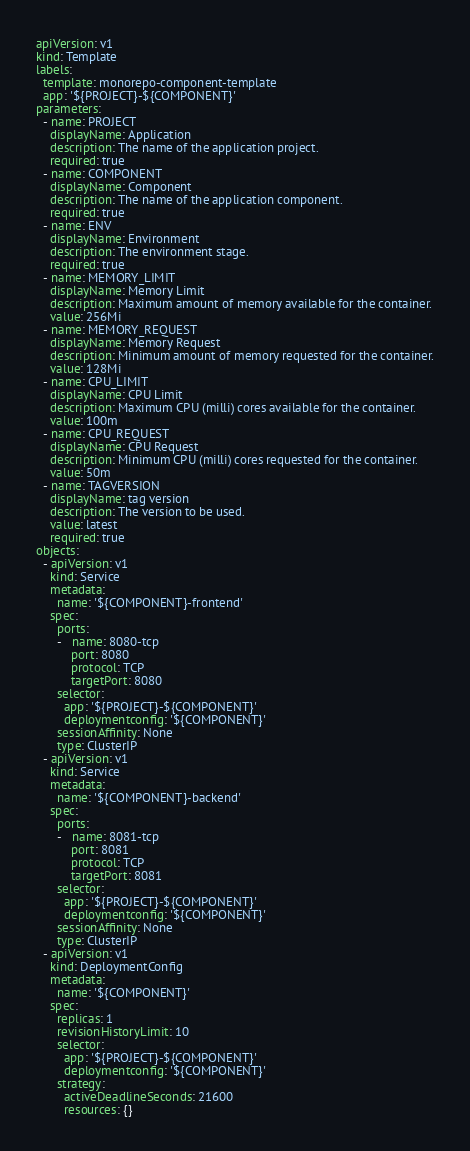Convert code to text. <code><loc_0><loc_0><loc_500><loc_500><_YAML_>apiVersion: v1
kind: Template
labels:
  template: monorepo-component-template
  app: '${PROJECT}-${COMPONENT}'
parameters:
  - name: PROJECT
    displayName: Application
    description: The name of the application project.
    required: true
  - name: COMPONENT
    displayName: Component
    description: The name of the application component.
    required: true
  - name: ENV
    displayName: Environment
    description: The environment stage.
    required: true
  - name: MEMORY_LIMIT
    displayName: Memory Limit
    description: Maximum amount of memory available for the container.
    value: 256Mi
  - name: MEMORY_REQUEST
    displayName: Memory Request
    description: Minimum amount of memory requested for the container.
    value: 128Mi
  - name: CPU_LIMIT
    displayName: CPU Limit
    description: Maximum CPU (milli) cores available for the container.
    value: 100m
  - name: CPU_REQUEST
    displayName: CPU Request
    description: Minimum CPU (milli) cores requested for the container.
    value: 50m
  - name: TAGVERSION
    displayName: tag version
    description: The version to be used.
    value: latest
    required: true
objects:
  - apiVersion: v1
    kind: Service
    metadata:
      name: '${COMPONENT}-frontend'
    spec:
      ports:
      -   name: 8080-tcp
          port: 8080
          protocol: TCP
          targetPort: 8080
      selector:
        app: '${PROJECT}-${COMPONENT}'
        deploymentconfig: '${COMPONENT}'
      sessionAffinity: None
      type: ClusterIP
  - apiVersion: v1
    kind: Service
    metadata:
      name: '${COMPONENT}-backend'
    spec:
      ports:
      -   name: 8081-tcp
          port: 8081
          protocol: TCP
          targetPort: 8081
      selector:
        app: '${PROJECT}-${COMPONENT}'
        deploymentconfig: '${COMPONENT}'
      sessionAffinity: None
      type: ClusterIP
  - apiVersion: v1
    kind: DeploymentConfig
    metadata:
      name: '${COMPONENT}'
    spec:
      replicas: 1
      revisionHistoryLimit: 10
      selector:
        app: '${PROJECT}-${COMPONENT}'
        deploymentconfig: '${COMPONENT}'
      strategy:
        activeDeadlineSeconds: 21600
        resources: {}</code> 